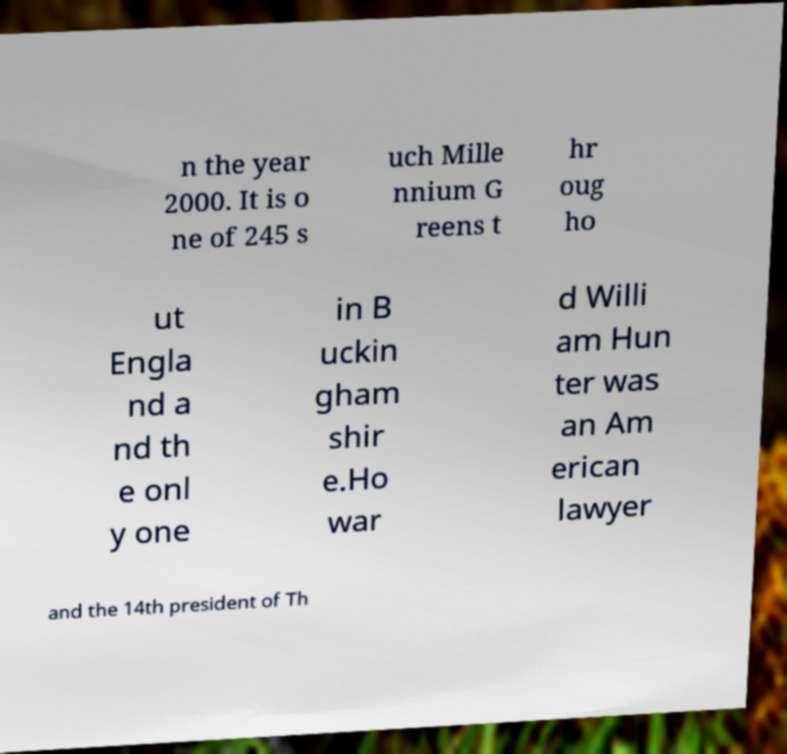I need the written content from this picture converted into text. Can you do that? n the year 2000. It is o ne of 245 s uch Mille nnium G reens t hr oug ho ut Engla nd a nd th e onl y one in B uckin gham shir e.Ho war d Willi am Hun ter was an Am erican lawyer and the 14th president of Th 